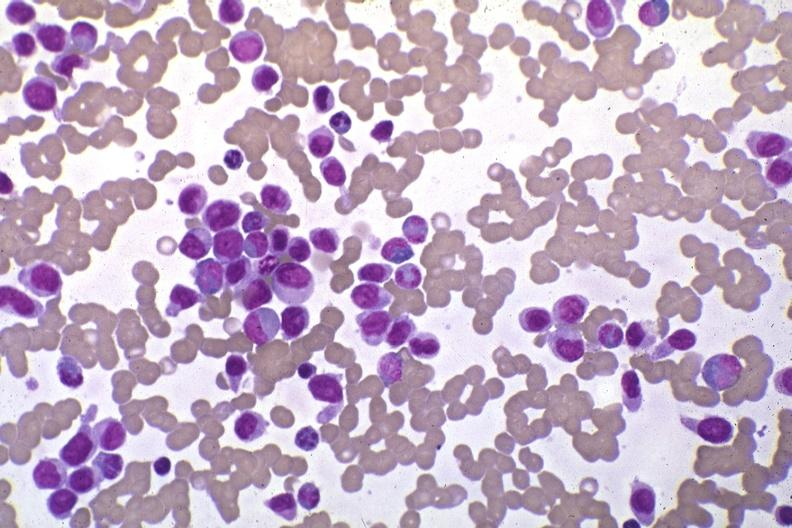s macerated stillborn present?
Answer the question using a single word or phrase. No 